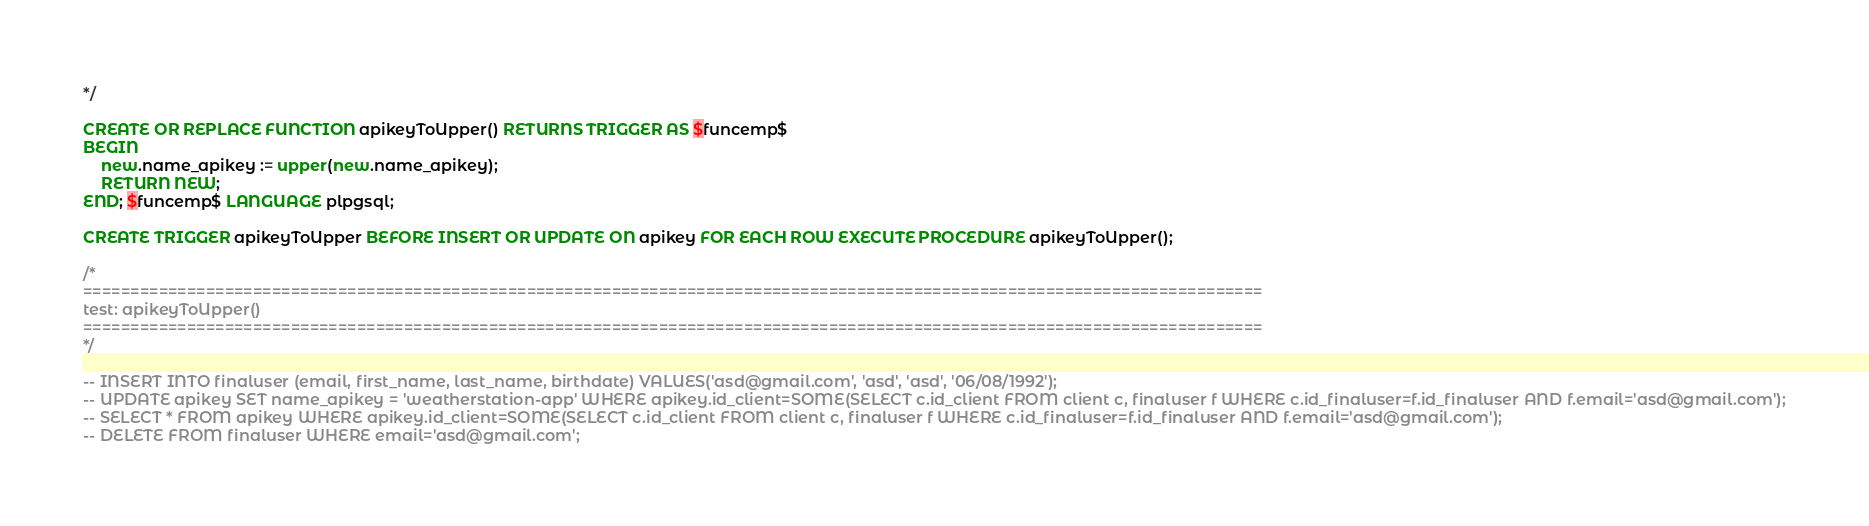Convert code to text. <code><loc_0><loc_0><loc_500><loc_500><_SQL_>*/

CREATE OR REPLACE FUNCTION apikeyToUpper() RETURNS TRIGGER AS $funcemp$
BEGIN
	new.name_apikey := upper(new.name_apikey);
	RETURN NEW;
END; $funcemp$ LANGUAGE plpgsql;

CREATE TRIGGER apikeyToUpper BEFORE INSERT OR UPDATE ON apikey FOR EACH ROW EXECUTE PROCEDURE apikeyToUpper();

/*
=============================================================================================================================
test: apikeyToUpper()
=============================================================================================================================
*/

-- INSERT INTO finaluser (email, first_name, last_name, birthdate) VALUES('asd@gmail.com', 'asd', 'asd', '06/08/1992');
-- UPDATE apikey SET name_apikey = 'weatherstation-app' WHERE apikey.id_client=SOME(SELECT c.id_client FROM client c, finaluser f WHERE c.id_finaluser=f.id_finaluser AND f.email='asd@gmail.com');
-- SELECT * FROM apikey WHERE apikey.id_client=SOME(SELECT c.id_client FROM client c, finaluser f WHERE c.id_finaluser=f.id_finaluser AND f.email='asd@gmail.com');
-- DELETE FROM finaluser WHERE email='asd@gmail.com';
</code> 